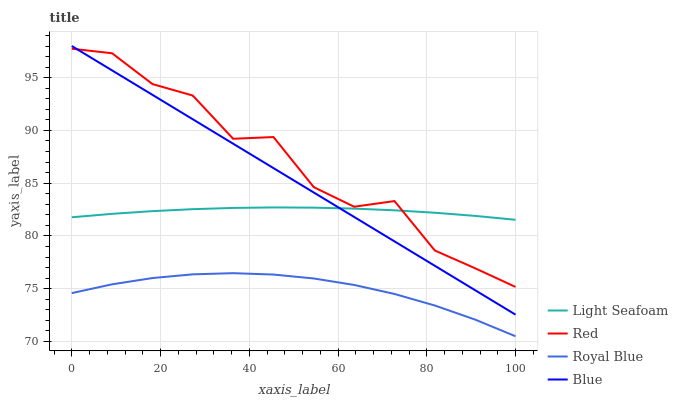Does Royal Blue have the minimum area under the curve?
Answer yes or no. Yes. Does Red have the maximum area under the curve?
Answer yes or no. Yes. Does Light Seafoam have the minimum area under the curve?
Answer yes or no. No. Does Light Seafoam have the maximum area under the curve?
Answer yes or no. No. Is Blue the smoothest?
Answer yes or no. Yes. Is Red the roughest?
Answer yes or no. Yes. Is Royal Blue the smoothest?
Answer yes or no. No. Is Royal Blue the roughest?
Answer yes or no. No. Does Royal Blue have the lowest value?
Answer yes or no. Yes. Does Light Seafoam have the lowest value?
Answer yes or no. No. Does Blue have the highest value?
Answer yes or no. Yes. Does Light Seafoam have the highest value?
Answer yes or no. No. Is Royal Blue less than Light Seafoam?
Answer yes or no. Yes. Is Red greater than Royal Blue?
Answer yes or no. Yes. Does Red intersect Blue?
Answer yes or no. Yes. Is Red less than Blue?
Answer yes or no. No. Is Red greater than Blue?
Answer yes or no. No. Does Royal Blue intersect Light Seafoam?
Answer yes or no. No. 